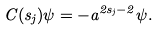<formula> <loc_0><loc_0><loc_500><loc_500>C ( s _ { j } ) \psi = - a ^ { 2 s _ { j } - 2 } \psi .</formula> 